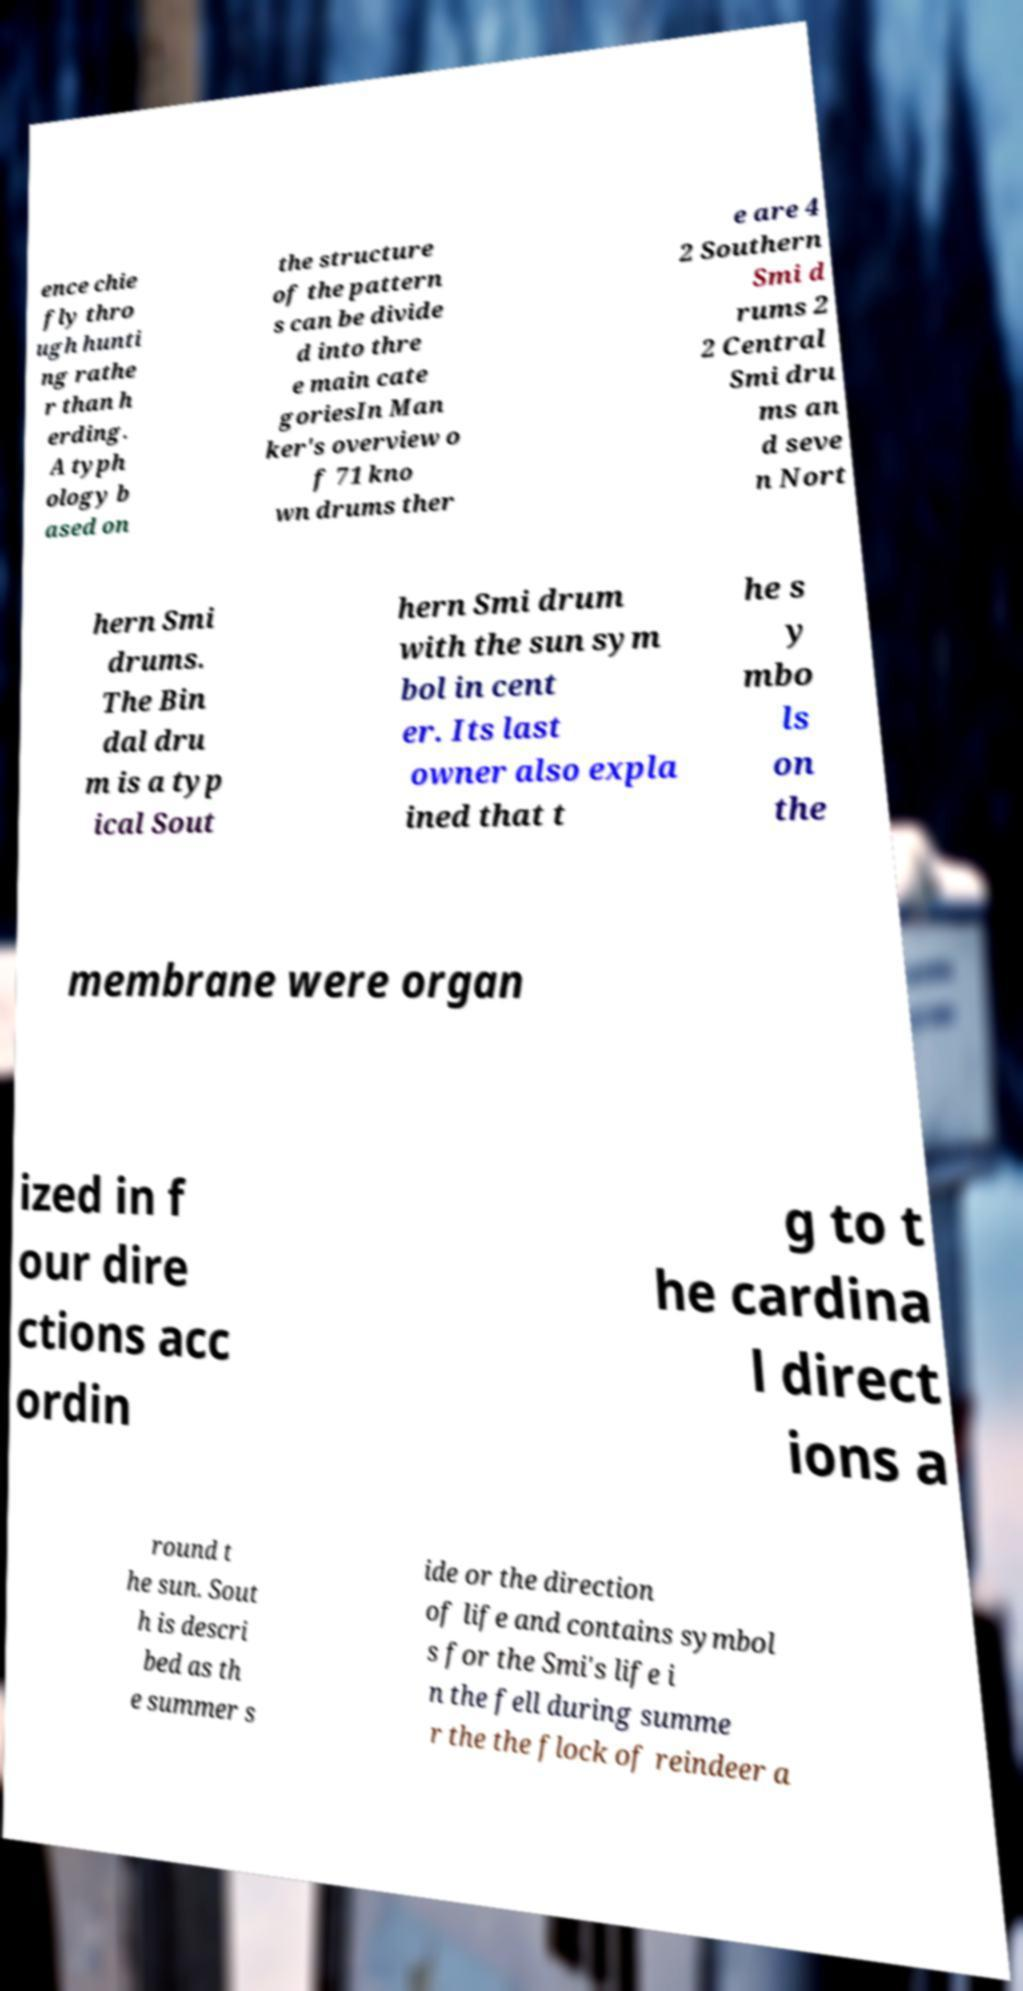For documentation purposes, I need the text within this image transcribed. Could you provide that? ence chie fly thro ugh hunti ng rathe r than h erding. A typh ology b ased on the structure of the pattern s can be divide d into thre e main cate goriesIn Man ker's overview o f 71 kno wn drums ther e are 4 2 Southern Smi d rums 2 2 Central Smi dru ms an d seve n Nort hern Smi drums. The Bin dal dru m is a typ ical Sout hern Smi drum with the sun sym bol in cent er. Its last owner also expla ined that t he s y mbo ls on the membrane were organ ized in f our dire ctions acc ordin g to t he cardina l direct ions a round t he sun. Sout h is descri bed as th e summer s ide or the direction of life and contains symbol s for the Smi's life i n the fell during summe r the the flock of reindeer a 